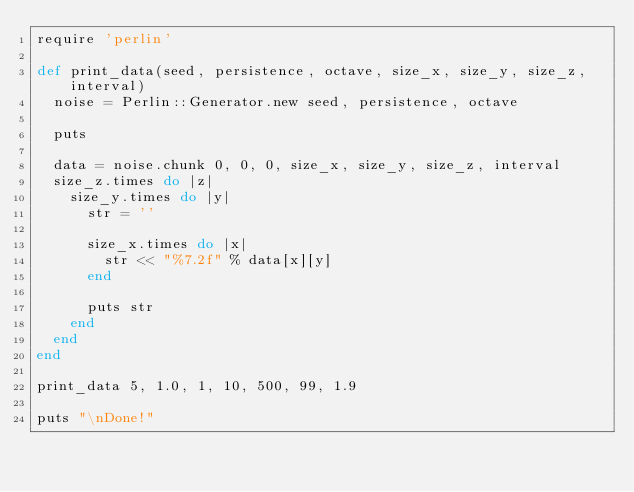Convert code to text. <code><loc_0><loc_0><loc_500><loc_500><_Ruby_>require 'perlin'

def print_data(seed, persistence, octave, size_x, size_y, size_z, interval)
  noise = Perlin::Generator.new seed, persistence, octave

  puts

  data = noise.chunk 0, 0, 0, size_x, size_y, size_z, interval
  size_z.times do |z|
    size_y.times do |y|
      str = ''

      size_x.times do |x|
        str << "%7.2f" % data[x][y]
      end

      puts str
    end
  end
end

print_data 5, 1.0, 1, 10, 500, 99, 1.9

puts "\nDone!"</code> 